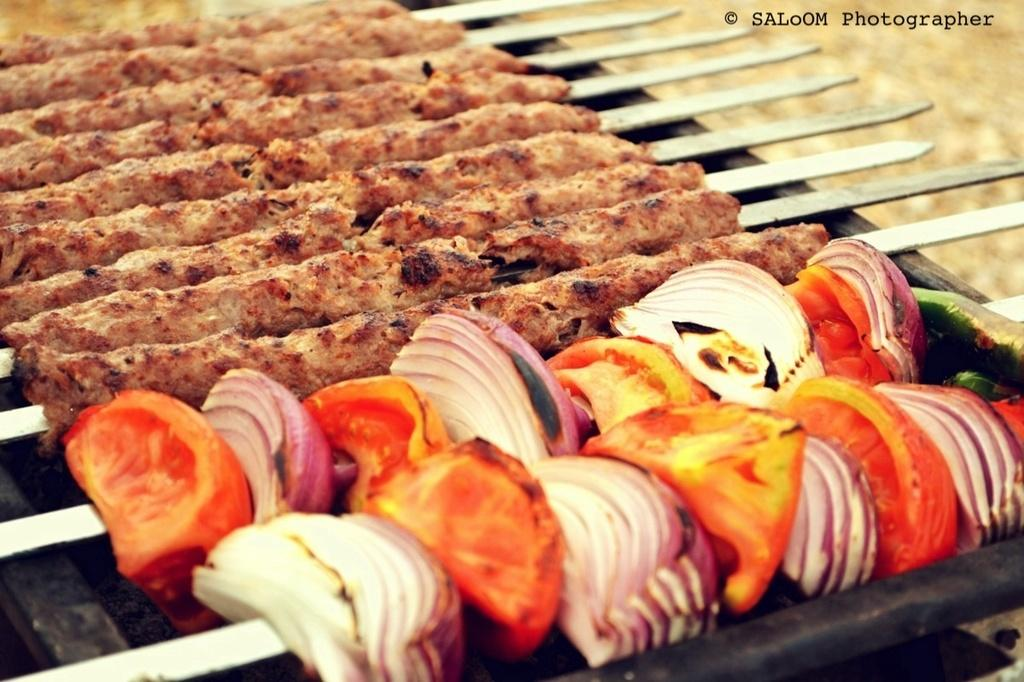What is being prepared on the grills in the image? There are kebabs being prepared on the grills in the image. What type of vegetable can be seen in the image? There are tomato pieces and onion pieces in the image. What type of writing can be seen on the jeans in the image? There are no jeans present in the image, so it is not possible to determine if there is any writing on them. 